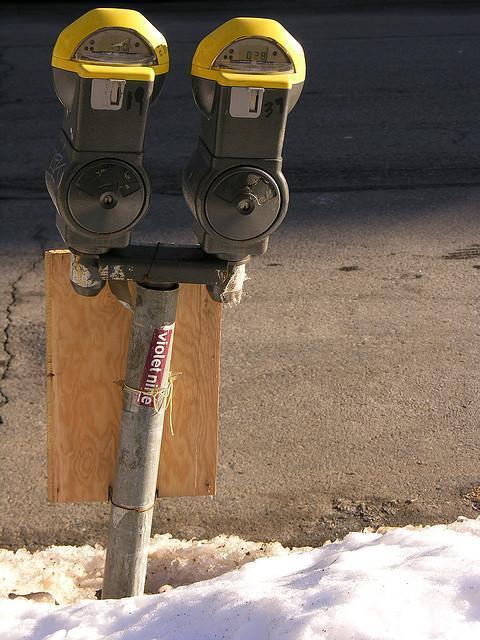How many parking meters are in the photo?
Give a very brief answer. 2. How many people are standing near a wall?
Give a very brief answer. 0. 